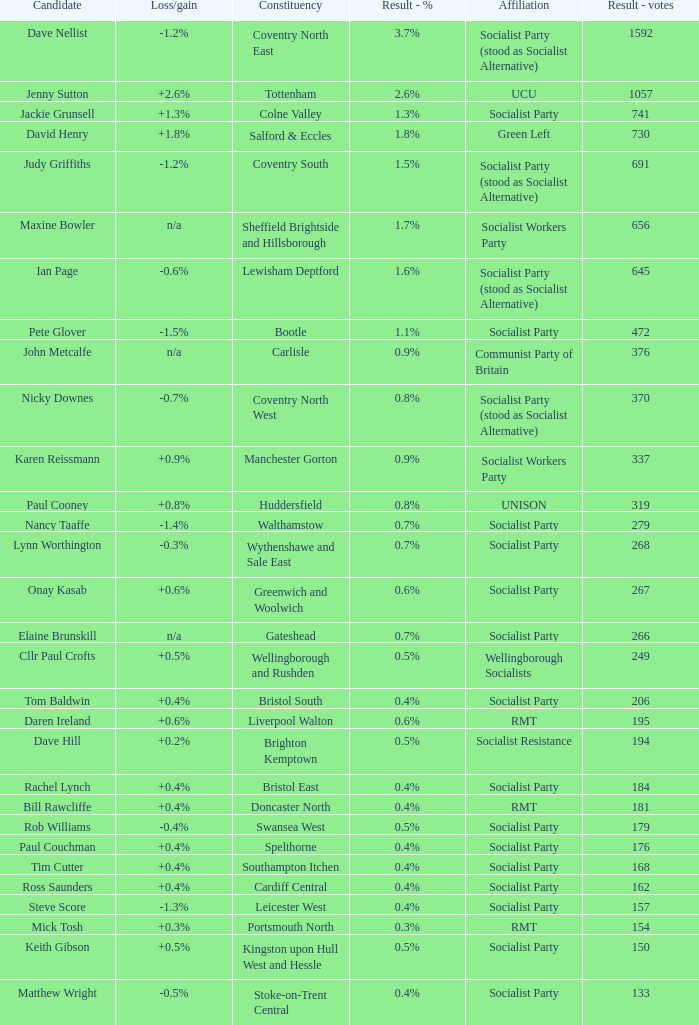How many values for constituency for the vote result of 162? 1.0. 